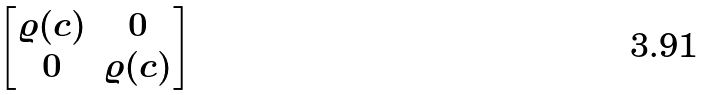<formula> <loc_0><loc_0><loc_500><loc_500>\begin{bmatrix} \varrho ( c ) & 0 \\ 0 & \varrho ( c ) \end{bmatrix}</formula> 